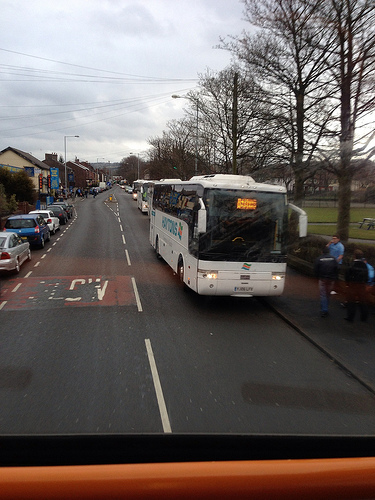<image>
Can you confirm if the tree is on the bus? No. The tree is not positioned on the bus. They may be near each other, but the tree is not supported by or resting on top of the bus. 